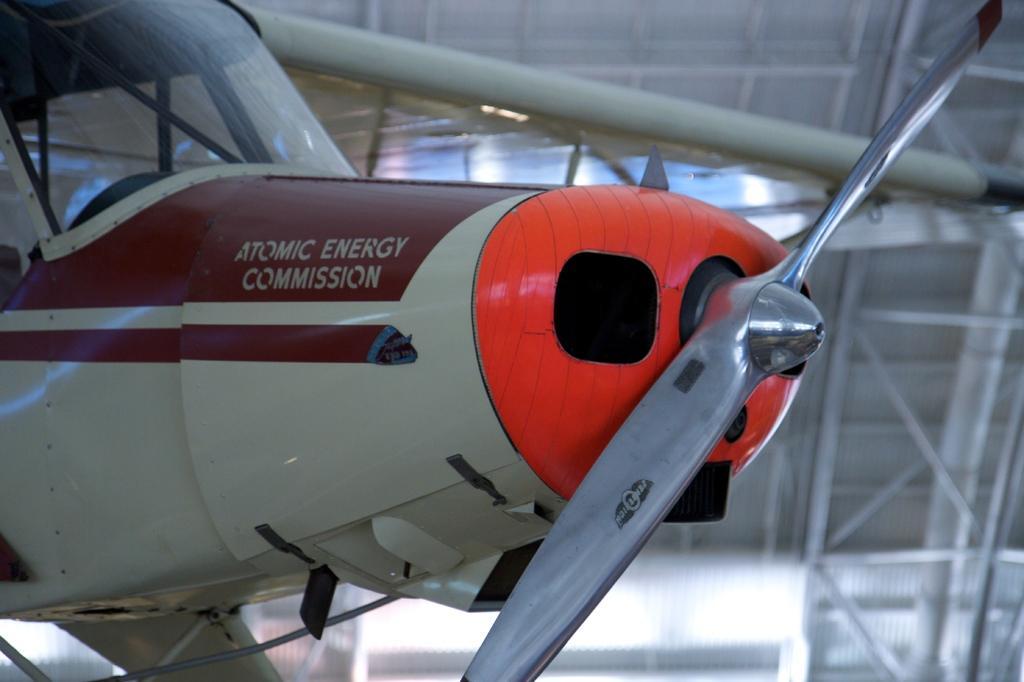In one or two sentences, can you explain what this image depicts? In this image, I can see an aircraft. This is a propeller and a wing, which are attached to an aircraft. I think this is a cockpit. The background looks blurry. 